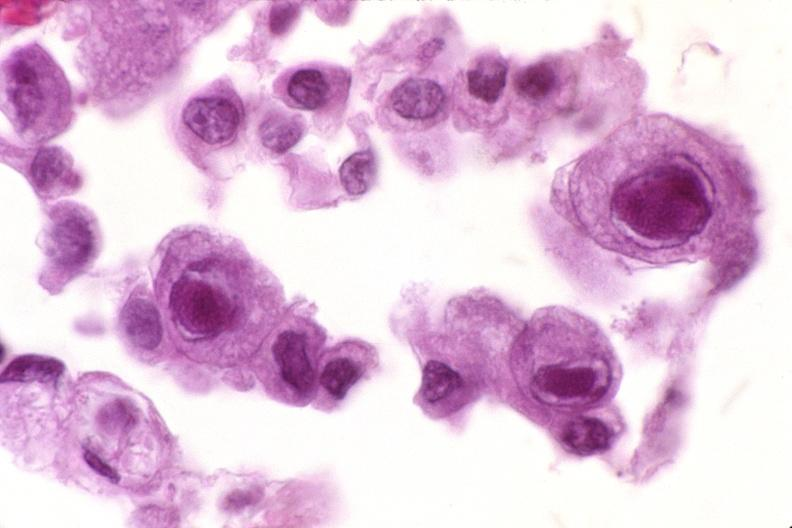where is this?
Answer the question using a single word or phrase. Lung 